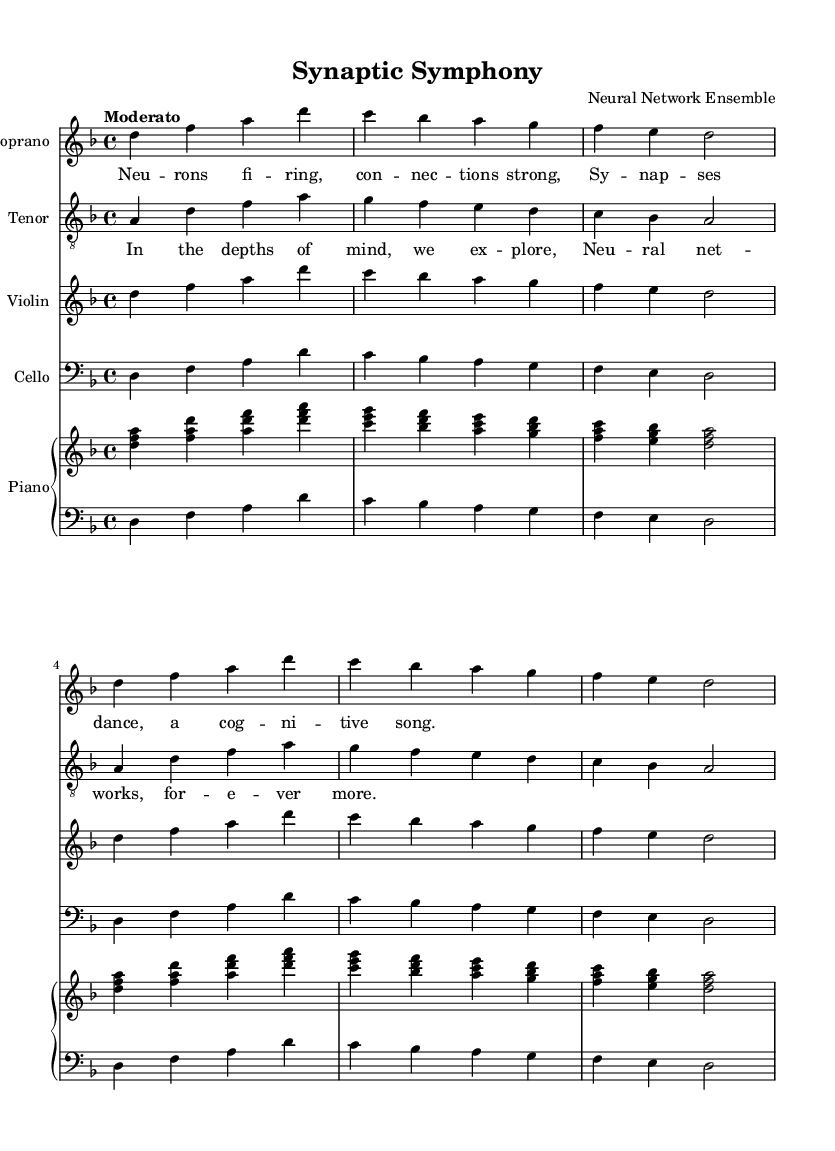What is the key signature of this music? The key signature is indicated at the beginning of the score. It shows two flats (B♭ and E♭), which indicates it's in D minor.
Answer: D minor What is the time signature of this music? The time signature is found at the beginning of the score, showing a 4 over a 4, which means there are four beats per measure.
Answer: 4/4 What tempo marking is indicated for this piece? The tempo is mentioned at the beginning of the score as "Moderato," which indicates a moderate speed.
Answer: Moderato How many different vocal parts are present in this score? By counting the different staffs designated for vocal parts, we see there is a Soprano and a Tenor, totaling two distinct vocal sections.
Answer: Two What is the first lyric line sung by the soprano? The first lyric line can be found beneath the Soprano part, and it reads “Neurons firing, connections strong.”
Answer: Neurons firing, connections strong What do the lyrics in the chorus suggest about the thematic focus of the opera? The lyrics from the chorus refer to exploration and continued discovery within neural networks, reflecting a cognitive neuroscience theme.
Answer: Neural networks, forever more What instrument plays the right-hand part of the piano? The right-hand part of the piano is indicated on the upper staff of the Piano staff, which is labeled for the right hand playing chords throughout the piece.
Answer: Piano Right Hand 